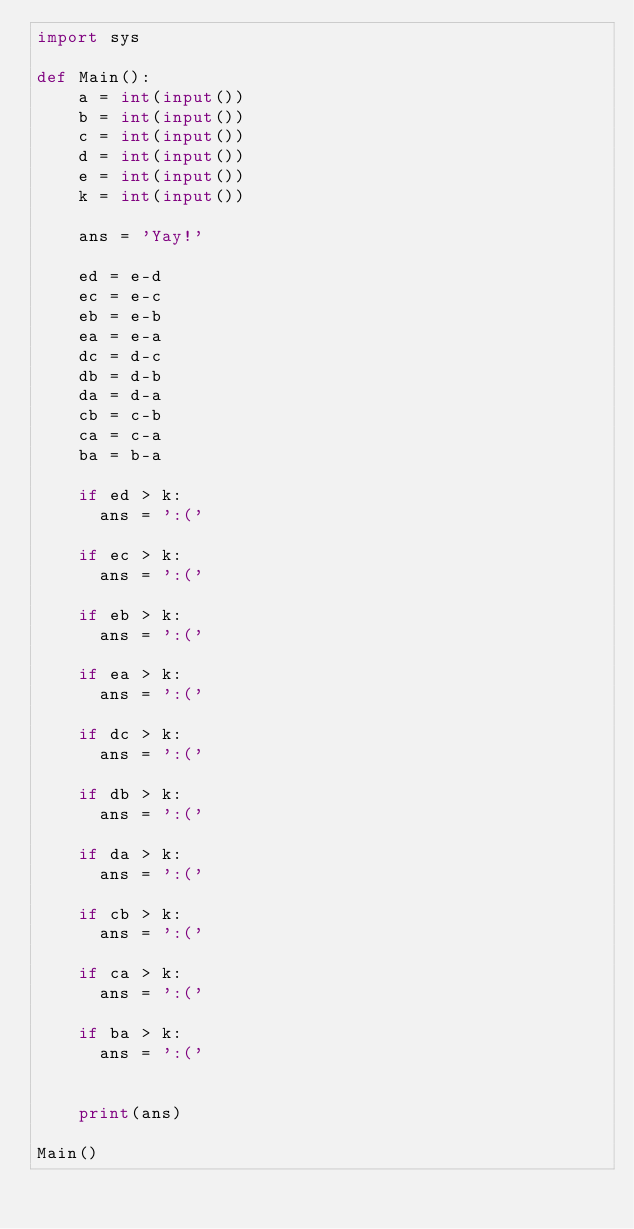Convert code to text. <code><loc_0><loc_0><loc_500><loc_500><_Python_>import sys

def Main():
    a = int(input())
    b = int(input())
    c = int(input())
    d = int(input())
    e = int(input())
    k = int(input())
    
    ans = 'Yay!'
    
    ed = e-d
    ec = e-c
    eb = e-b
    ea = e-a
    dc = d-c
    db = d-b
    da = d-a
    cb = c-b
    ca = c-a
    ba = b-a
    
    if ed > k:
    	ans = ':('
    
    if ec > k:
    	ans = ':('

    if eb > k:
    	ans = ':('
    
    if ea > k:
    	ans = ':('
        
    if dc > k:
    	ans = ':('
        
    if db > k:
    	ans = ':('
    
    if da > k:
    	ans = ':('
    
    if cb > k:	
    	ans = ':('
        
    if ca > k:
    	ans = ':('
        
    if ba > k:
    	ans = ':('
       
    
    print(ans)

Main()</code> 